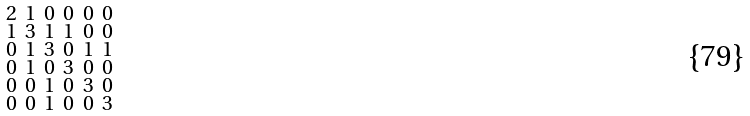<formula> <loc_0><loc_0><loc_500><loc_500>\begin{smallmatrix} 2 & 1 & 0 & 0 & 0 & 0 \\ 1 & 3 & 1 & 1 & 0 & 0 \\ 0 & 1 & 3 & 0 & 1 & 1 \\ 0 & 1 & 0 & 3 & 0 & 0 \\ 0 & 0 & 1 & 0 & 3 & 0 \\ 0 & 0 & 1 & 0 & 0 & 3 \end{smallmatrix}</formula> 